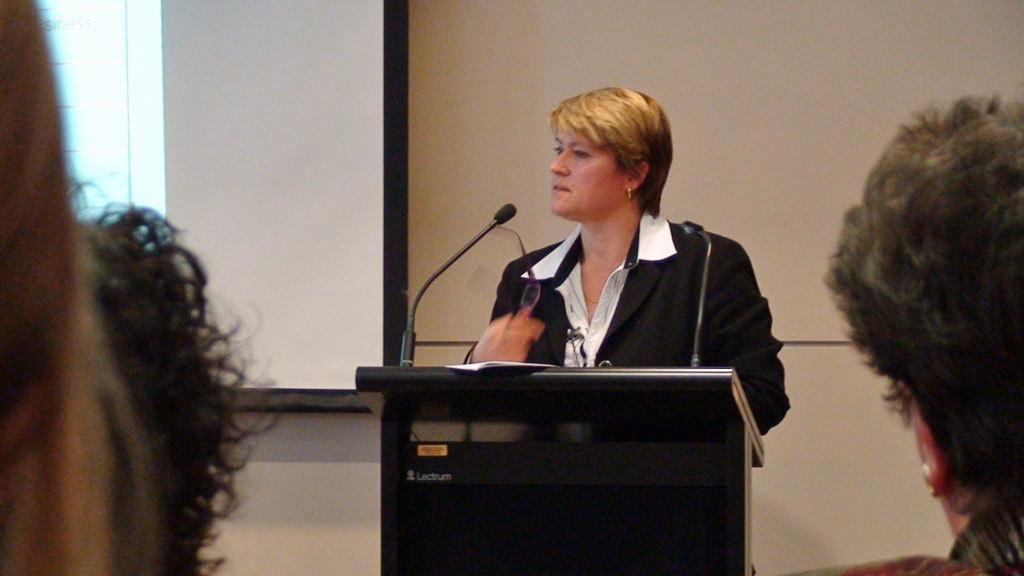How would you summarize this image in a sentence or two? In this image in the middle there is a podium in front of that there is a woman she wears short her hair is short. On the right there is a person. In the background there is a wall and window. 